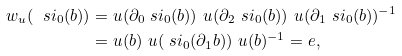Convert formula to latex. <formula><loc_0><loc_0><loc_500><loc_500>w _ { u } ( \ s i _ { 0 } ( b ) ) & = u ( \partial _ { 0 } \ s i _ { 0 } ( b ) ) \ u ( \partial _ { 2 } \ s i _ { 0 } ( b ) ) \ u ( \partial _ { 1 } \ s i _ { 0 } ( b ) ) ^ { - 1 } \\ & = u ( b ) \ u ( \ s i _ { 0 } ( \partial _ { 1 } b ) ) \ u ( b ) ^ { - 1 } = e ,</formula> 